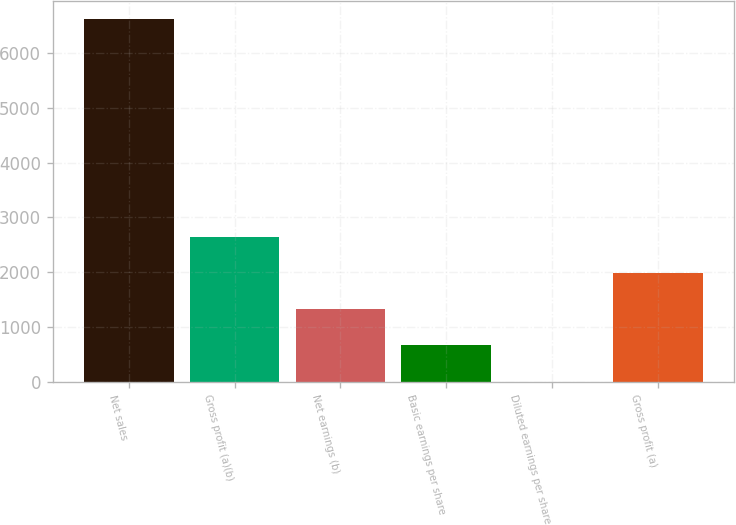Convert chart. <chart><loc_0><loc_0><loc_500><loc_500><bar_chart><fcel>Net sales<fcel>Gross profit (a)(b)<fcel>Net earnings (b)<fcel>Basic earnings per share<fcel>Diluted earnings per share<fcel>Gross profit (a)<nl><fcel>6621.5<fcel>2650.5<fcel>1326.82<fcel>664.98<fcel>3.14<fcel>1988.66<nl></chart> 